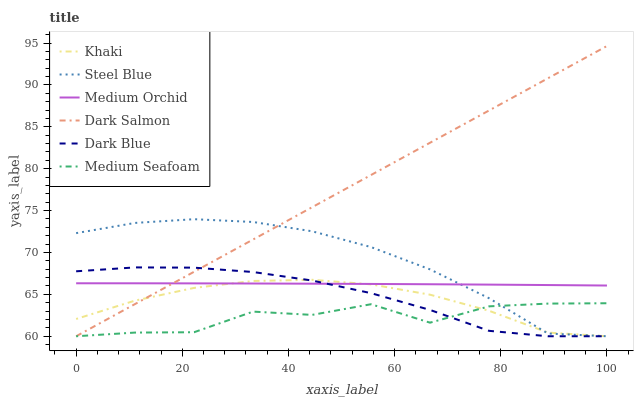Does Medium Seafoam have the minimum area under the curve?
Answer yes or no. Yes. Does Dark Salmon have the maximum area under the curve?
Answer yes or no. Yes. Does Medium Orchid have the minimum area under the curve?
Answer yes or no. No. Does Medium Orchid have the maximum area under the curve?
Answer yes or no. No. Is Dark Salmon the smoothest?
Answer yes or no. Yes. Is Medium Seafoam the roughest?
Answer yes or no. Yes. Is Medium Orchid the smoothest?
Answer yes or no. No. Is Medium Orchid the roughest?
Answer yes or no. No. Does Khaki have the lowest value?
Answer yes or no. Yes. Does Medium Orchid have the lowest value?
Answer yes or no. No. Does Dark Salmon have the highest value?
Answer yes or no. Yes. Does Medium Orchid have the highest value?
Answer yes or no. No. Is Medium Seafoam less than Medium Orchid?
Answer yes or no. Yes. Is Medium Orchid greater than Medium Seafoam?
Answer yes or no. Yes. Does Steel Blue intersect Khaki?
Answer yes or no. Yes. Is Steel Blue less than Khaki?
Answer yes or no. No. Is Steel Blue greater than Khaki?
Answer yes or no. No. Does Medium Seafoam intersect Medium Orchid?
Answer yes or no. No. 